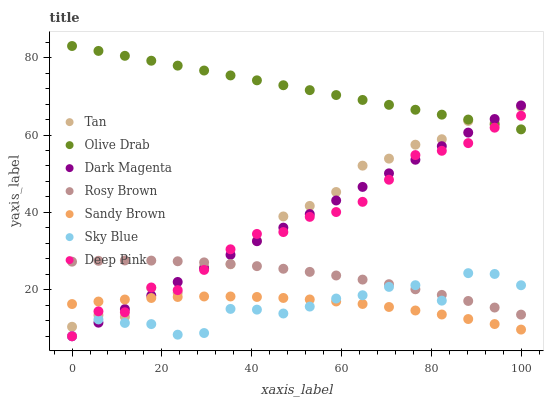Does Sky Blue have the minimum area under the curve?
Answer yes or no. Yes. Does Olive Drab have the maximum area under the curve?
Answer yes or no. Yes. Does Dark Magenta have the minimum area under the curve?
Answer yes or no. No. Does Dark Magenta have the maximum area under the curve?
Answer yes or no. No. Is Olive Drab the smoothest?
Answer yes or no. Yes. Is Tan the roughest?
Answer yes or no. Yes. Is Dark Magenta the smoothest?
Answer yes or no. No. Is Dark Magenta the roughest?
Answer yes or no. No. Does Deep Pink have the lowest value?
Answer yes or no. Yes. Does Rosy Brown have the lowest value?
Answer yes or no. No. Does Olive Drab have the highest value?
Answer yes or no. Yes. Does Dark Magenta have the highest value?
Answer yes or no. No. Is Sky Blue less than Olive Drab?
Answer yes or no. Yes. Is Olive Drab greater than Sky Blue?
Answer yes or no. Yes. Does Deep Pink intersect Olive Drab?
Answer yes or no. Yes. Is Deep Pink less than Olive Drab?
Answer yes or no. No. Is Deep Pink greater than Olive Drab?
Answer yes or no. No. Does Sky Blue intersect Olive Drab?
Answer yes or no. No. 